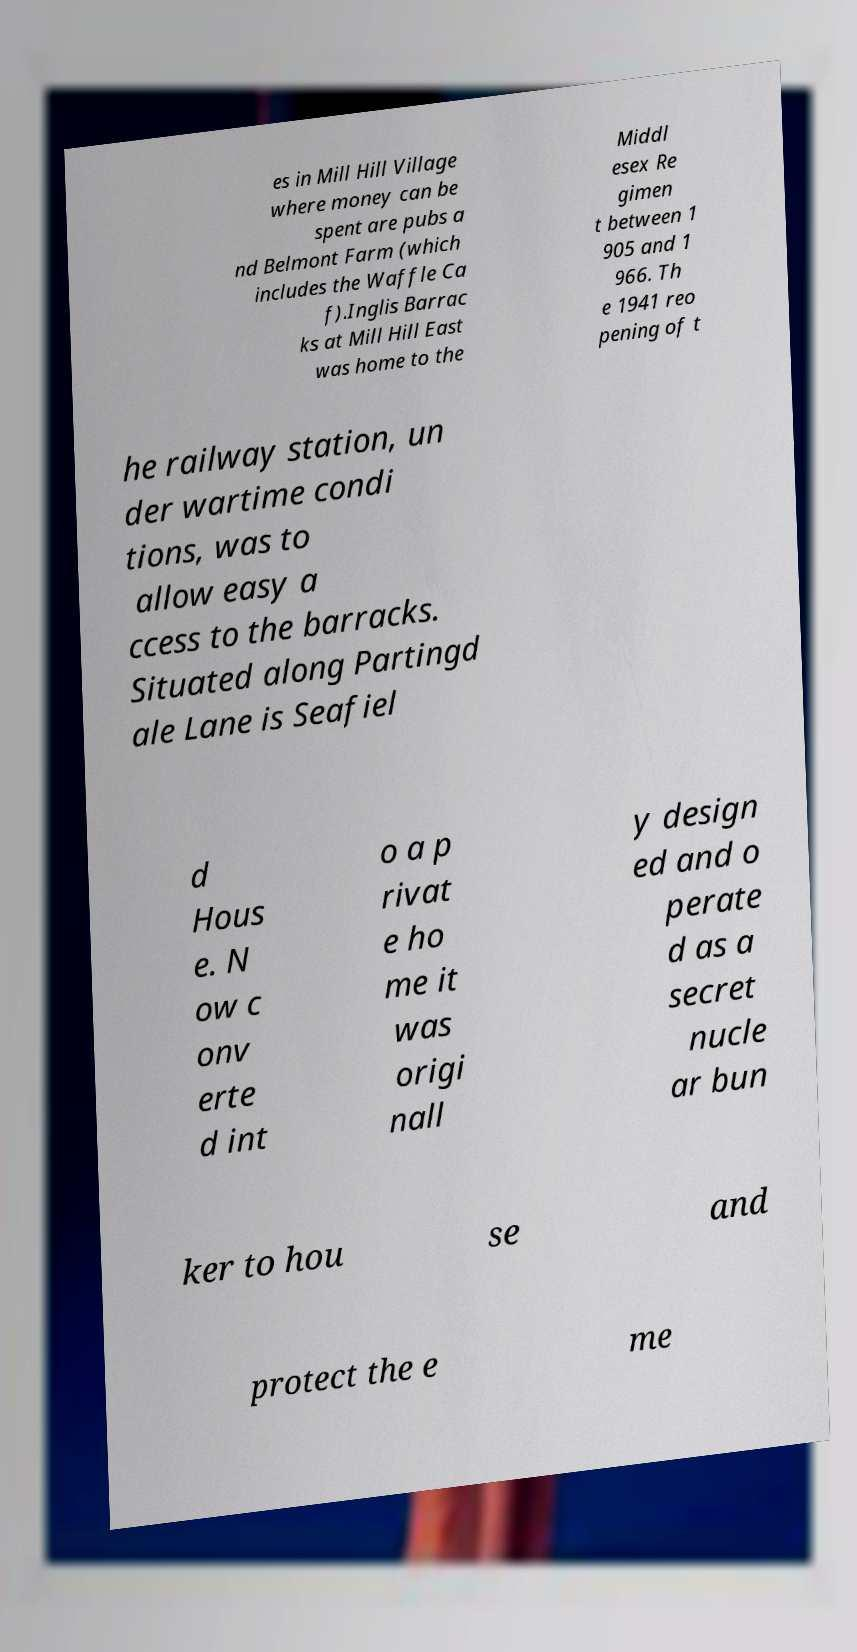Could you extract and type out the text from this image? es in Mill Hill Village where money can be spent are pubs a nd Belmont Farm (which includes the Waffle Ca f).Inglis Barrac ks at Mill Hill East was home to the Middl esex Re gimen t between 1 905 and 1 966. Th e 1941 reo pening of t he railway station, un der wartime condi tions, was to allow easy a ccess to the barracks. Situated along Partingd ale Lane is Seafiel d Hous e. N ow c onv erte d int o a p rivat e ho me it was origi nall y design ed and o perate d as a secret nucle ar bun ker to hou se and protect the e me 